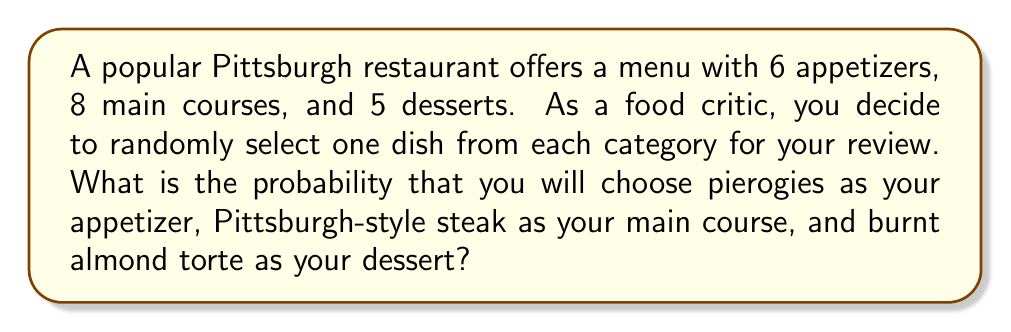Can you answer this question? To solve this problem, we need to use the concept of probability in discrete mathematics. Let's break it down step-by-step:

1. First, we need to consider the total number of possible combinations for a three-course meal from this menu. We can calculate this using the multiplication principle:

   $$ \text{Total combinations} = 6 \times 8 \times 5 = 240 $$

2. Now, we're interested in a specific combination: pierogies, Pittsburgh-style steak, and burnt almond torte. Each of these is one specific item in its respective category.

3. The probability of selecting this exact combination is the product of the individual probabilities of selecting each item from its category:

   $$ P(\text{pierogies}) = \frac{1}{6} $$
   $$ P(\text{Pittsburgh-style steak}) = \frac{1}{8} $$
   $$ P(\text{burnt almond torte}) = \frac{1}{5} $$

4. The probability of selecting all three of these specific dishes is:

   $$ P(\text{all three}) = P(\text{pierogies}) \times P(\text{Pittsburgh-style steak}) \times P(\text{burnt almond torte}) $$

   $$ = \frac{1}{6} \times \frac{1}{8} \times \frac{1}{5} = \frac{1}{240} $$

5. We can verify this result by noting that there is only one favorable outcome (the specific combination we want) out of the total 240 possible combinations.

Therefore, the probability of selecting this specific combination of dishes is $\frac{1}{240}$.
Answer: $\frac{1}{240}$ or approximately $0.00417$ or $0.417\%$ 